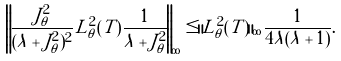<formula> <loc_0><loc_0><loc_500><loc_500>\left \| \frac { J _ { \theta } ^ { 2 } } { ( \lambda + J _ { \theta } ^ { 2 } ) ^ { 2 } } L _ { \theta } ^ { 2 } ( T ) \frac { 1 } { \lambda + J _ { \theta } ^ { 2 } } \right \| _ { \infty } \leq \| L _ { \theta } ^ { 2 } ( T ) \| _ { \infty } \frac { 1 } { 4 \lambda ( \lambda + 1 ) } .</formula> 